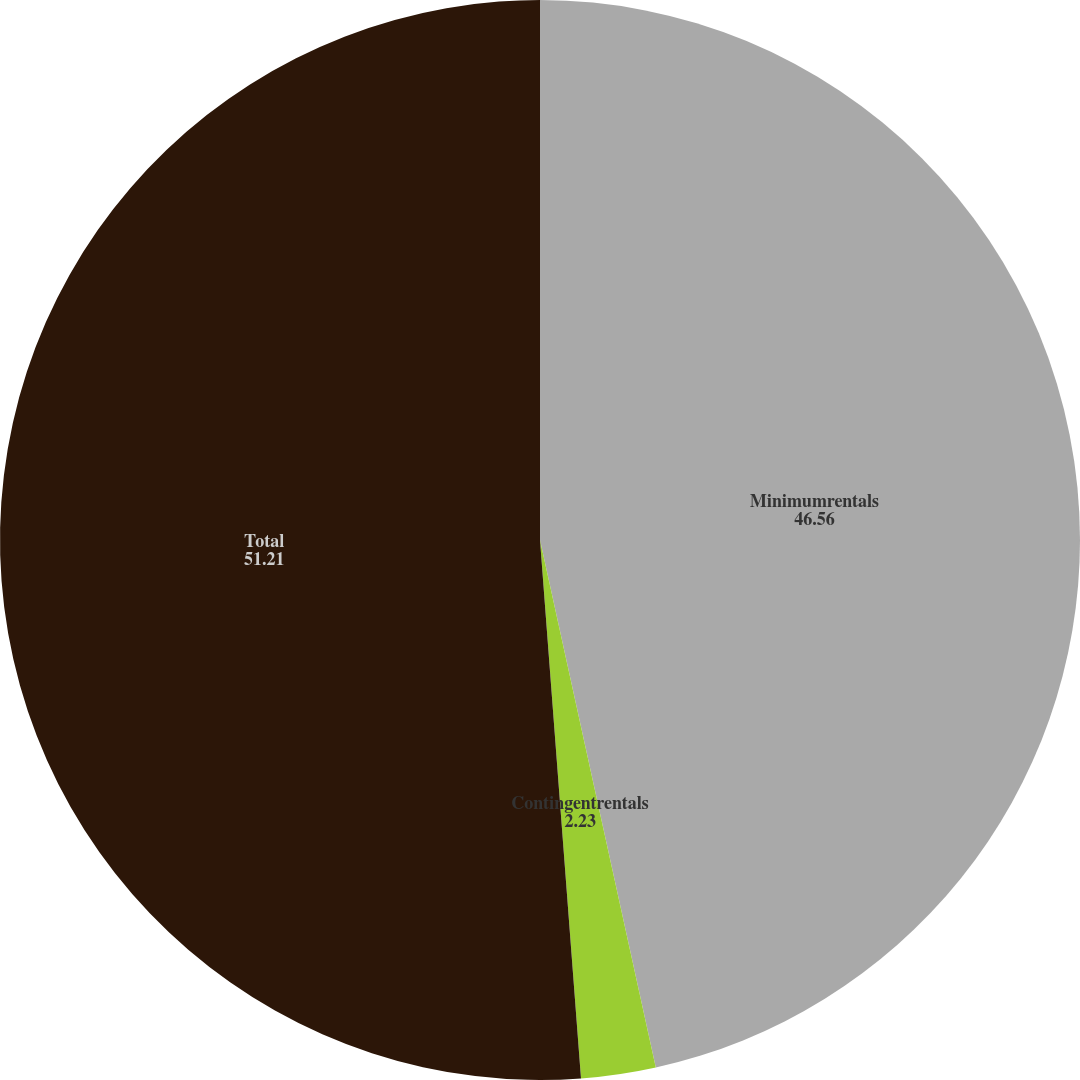Convert chart to OTSL. <chart><loc_0><loc_0><loc_500><loc_500><pie_chart><fcel>Minimumrentals<fcel>Contingentrentals<fcel>Total<nl><fcel>46.56%<fcel>2.23%<fcel>51.21%<nl></chart> 